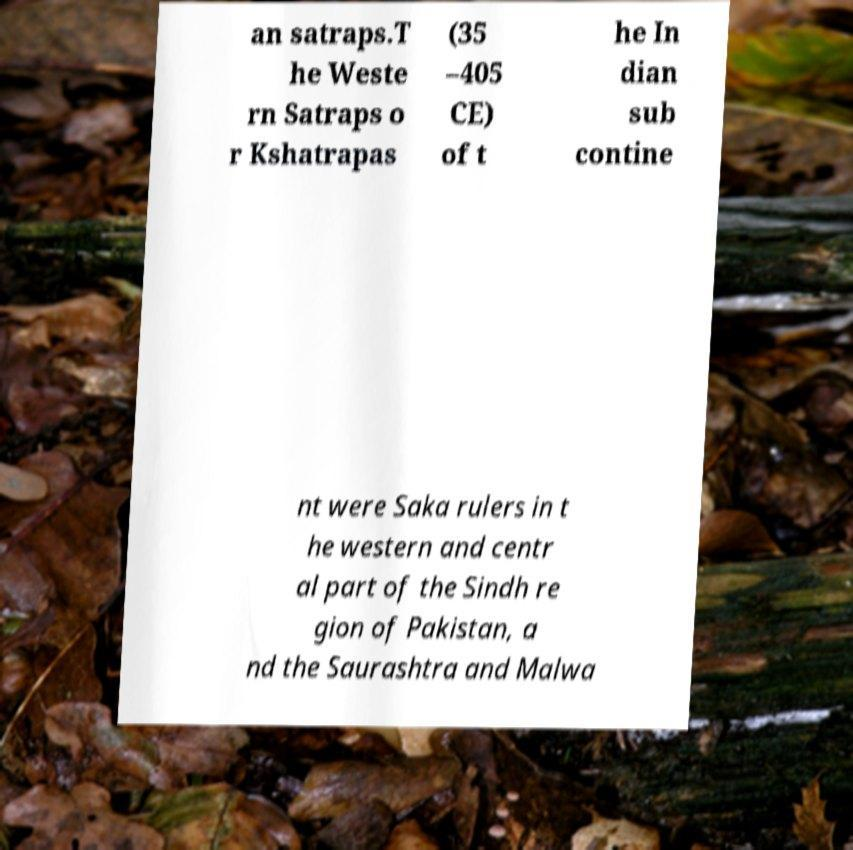There's text embedded in this image that I need extracted. Can you transcribe it verbatim? an satraps.T he Weste rn Satraps o r Kshatrapas (35 –405 CE) of t he In dian sub contine nt were Saka rulers in t he western and centr al part of the Sindh re gion of Pakistan, a nd the Saurashtra and Malwa 